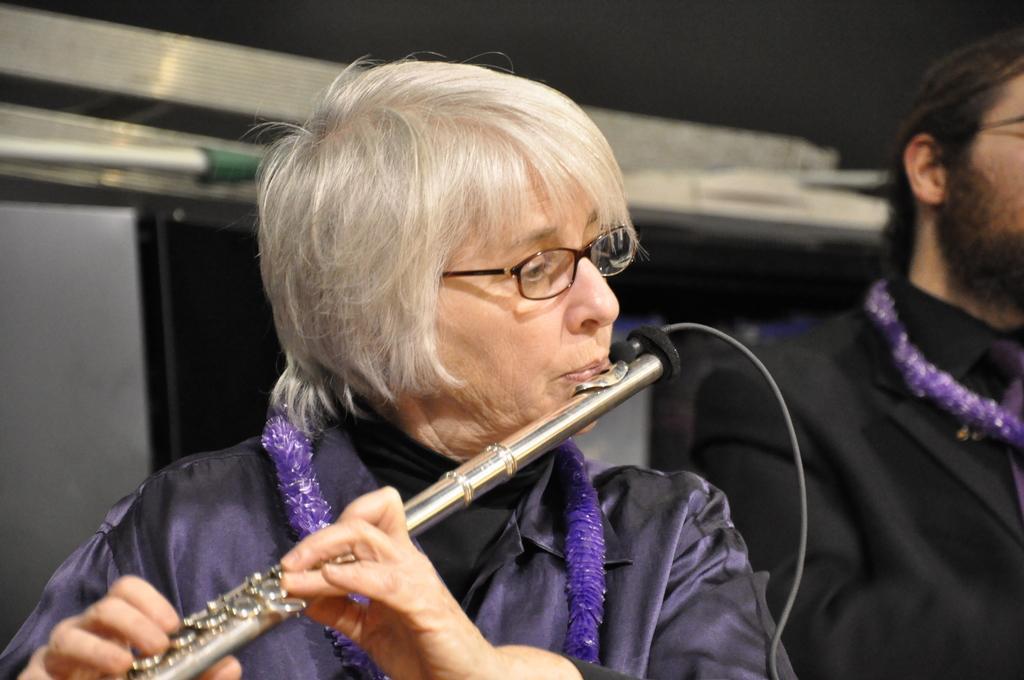How would you summarize this image in a sentence or two? In this picture there is a woman playing a flute and holding the flute with both the hands. There is a man standing on to her left. 